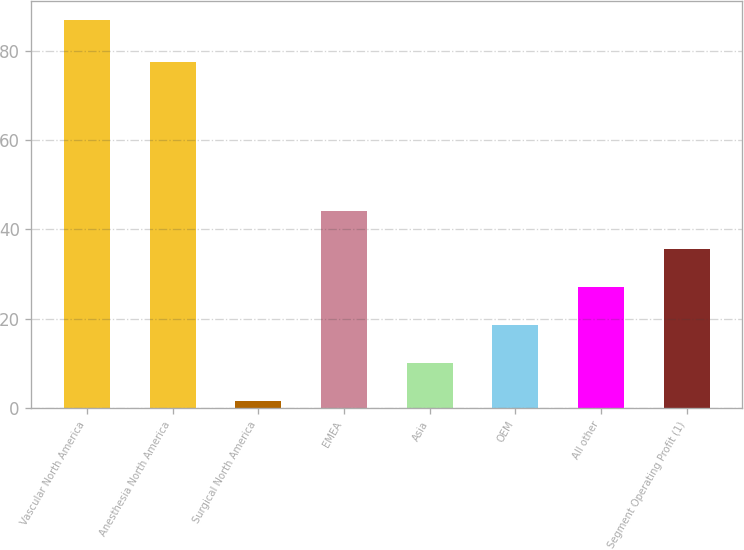Convert chart. <chart><loc_0><loc_0><loc_500><loc_500><bar_chart><fcel>Vascular North America<fcel>Anesthesia North America<fcel>Surgical North America<fcel>EMEA<fcel>Asia<fcel>OEM<fcel>All other<fcel>Segment Operating Profit (1)<nl><fcel>86.8<fcel>77.4<fcel>1.5<fcel>44.15<fcel>10.03<fcel>18.56<fcel>27.09<fcel>35.62<nl></chart> 